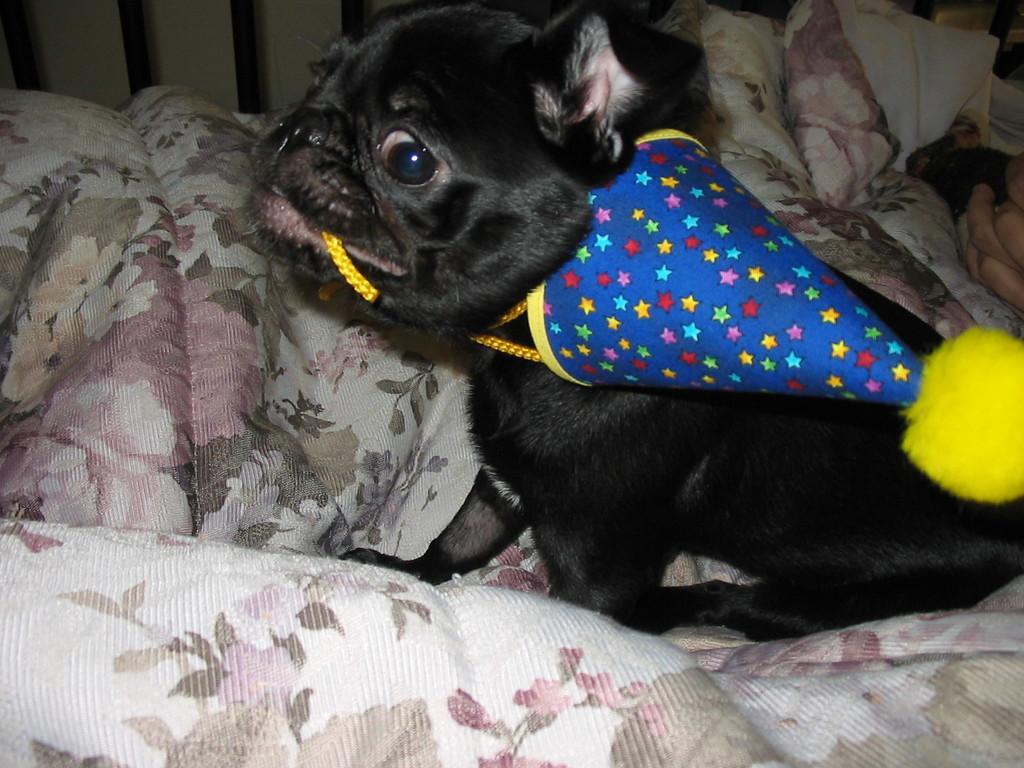Describe this image in one or two sentences. In this image I can see a black color dog is sitting on a blanket. The dog is wearing a party cap. 